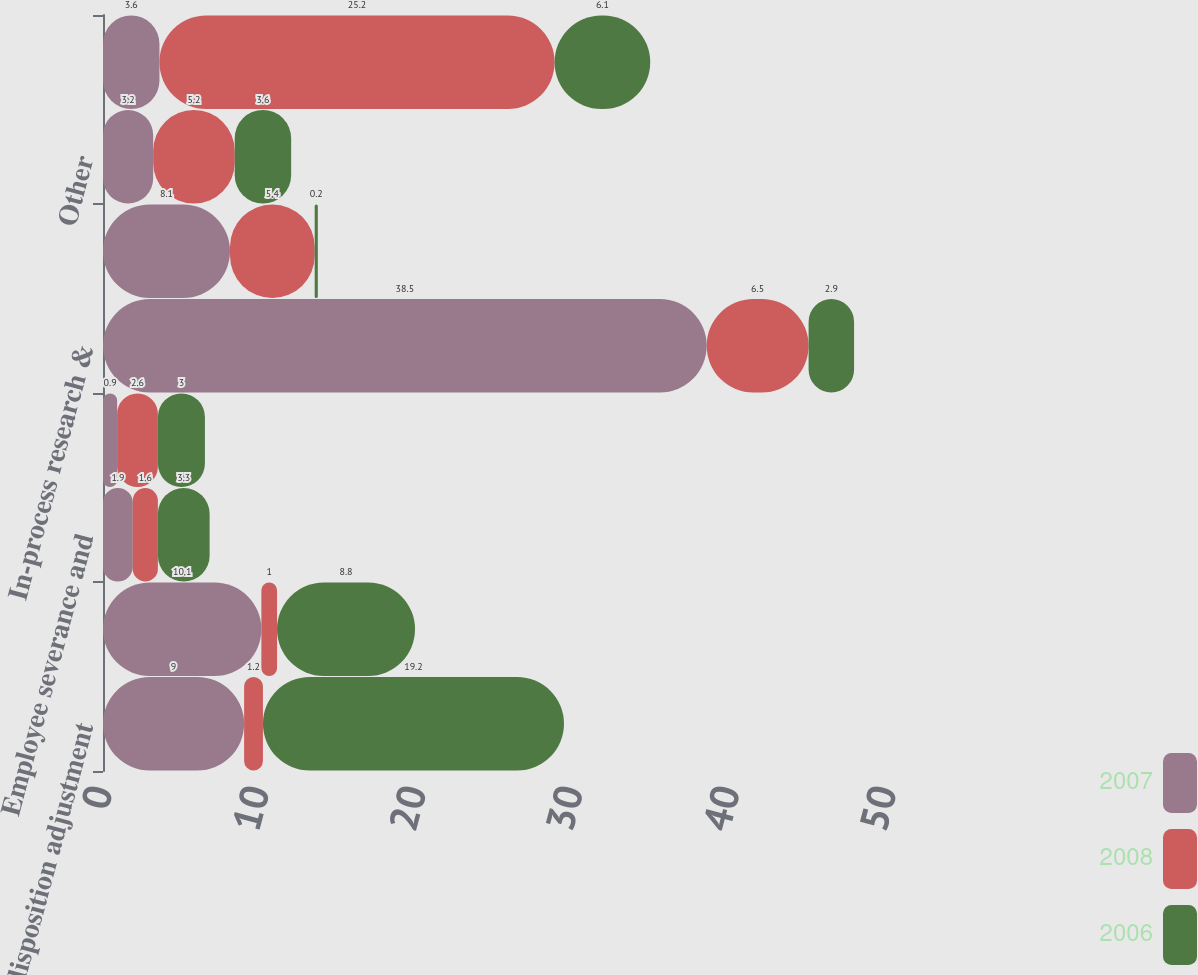<chart> <loc_0><loc_0><loc_500><loc_500><stacked_bar_chart><ecel><fcel>Gain on disposition adjustment<fcel>Consulting and professional<fcel>Employee severance and<fcel>Information technology<fcel>In-process research &<fcel>Sales agent and lease contract<fcel>Other<fcel>Acquisition Integration and<nl><fcel>2007<fcel>9<fcel>10.1<fcel>1.9<fcel>0.9<fcel>38.5<fcel>8.1<fcel>3.2<fcel>3.6<nl><fcel>2008<fcel>1.2<fcel>1<fcel>1.6<fcel>2.6<fcel>6.5<fcel>5.4<fcel>5.2<fcel>25.2<nl><fcel>2006<fcel>19.2<fcel>8.8<fcel>3.3<fcel>3<fcel>2.9<fcel>0.2<fcel>3.6<fcel>6.1<nl></chart> 